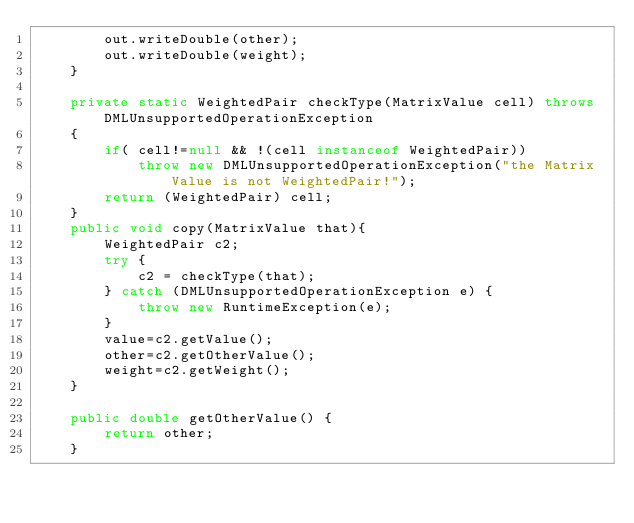<code> <loc_0><loc_0><loc_500><loc_500><_Java_>		out.writeDouble(other);
		out.writeDouble(weight);
	}

	private static WeightedPair checkType(MatrixValue cell) throws DMLUnsupportedOperationException
	{
		if( cell!=null && !(cell instanceof WeightedPair))
			throw new DMLUnsupportedOperationException("the Matrix Value is not WeightedPair!");
		return (WeightedPair) cell;
	}
	public void copy(MatrixValue that){
		WeightedPair c2;
		try {
			c2 = checkType(that);
		} catch (DMLUnsupportedOperationException e) {
			throw new RuntimeException(e);
		}
		value=c2.getValue();
		other=c2.getOtherValue();
		weight=c2.getWeight();
	}
	
	public double getOtherValue() {
		return other;
	}
	</code> 